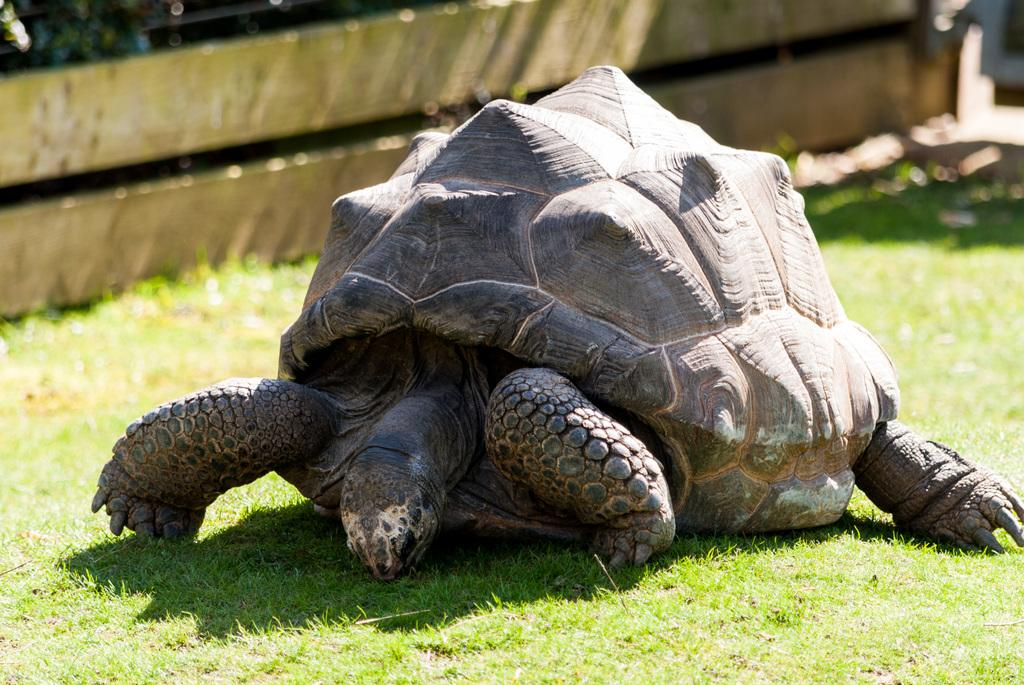What type of animal is on the ground in the image? There is a tortoise on the ground in the image. What is the surface on which the tortoise is standing? There is grass on the ground in the image. What can be seen in the background of the image? There is a wooden wall in the background of the image. Is it raining in the image? There is no indication of rain in the image; it only shows a tortoise on grass with a wooden wall in the background. 